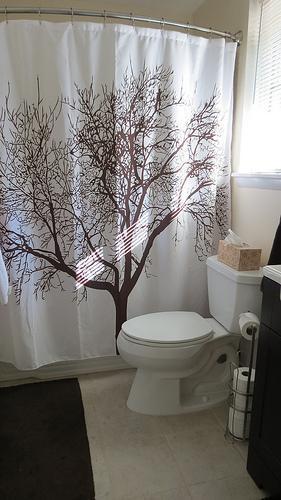How many toilets are in the photo?
Give a very brief answer. 1. 